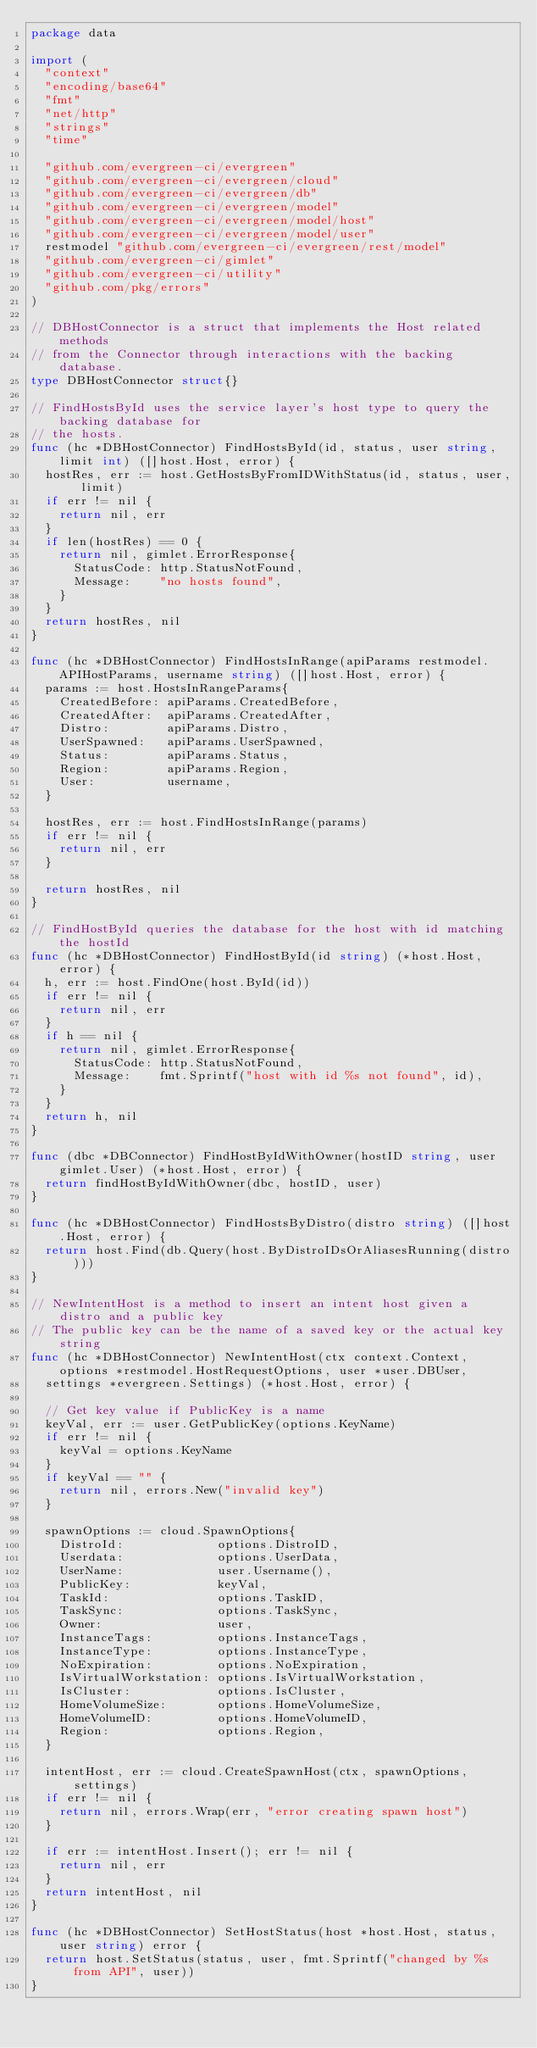Convert code to text. <code><loc_0><loc_0><loc_500><loc_500><_Go_>package data

import (
	"context"
	"encoding/base64"
	"fmt"
	"net/http"
	"strings"
	"time"

	"github.com/evergreen-ci/evergreen"
	"github.com/evergreen-ci/evergreen/cloud"
	"github.com/evergreen-ci/evergreen/db"
	"github.com/evergreen-ci/evergreen/model"
	"github.com/evergreen-ci/evergreen/model/host"
	"github.com/evergreen-ci/evergreen/model/user"
	restmodel "github.com/evergreen-ci/evergreen/rest/model"
	"github.com/evergreen-ci/gimlet"
	"github.com/evergreen-ci/utility"
	"github.com/pkg/errors"
)

// DBHostConnector is a struct that implements the Host related methods
// from the Connector through interactions with the backing database.
type DBHostConnector struct{}

// FindHostsById uses the service layer's host type to query the backing database for
// the hosts.
func (hc *DBHostConnector) FindHostsById(id, status, user string, limit int) ([]host.Host, error) {
	hostRes, err := host.GetHostsByFromIDWithStatus(id, status, user, limit)
	if err != nil {
		return nil, err
	}
	if len(hostRes) == 0 {
		return nil, gimlet.ErrorResponse{
			StatusCode: http.StatusNotFound,
			Message:    "no hosts found",
		}
	}
	return hostRes, nil
}

func (hc *DBHostConnector) FindHostsInRange(apiParams restmodel.APIHostParams, username string) ([]host.Host, error) {
	params := host.HostsInRangeParams{
		CreatedBefore: apiParams.CreatedBefore,
		CreatedAfter:  apiParams.CreatedAfter,
		Distro:        apiParams.Distro,
		UserSpawned:   apiParams.UserSpawned,
		Status:        apiParams.Status,
		Region:        apiParams.Region,
		User:          username,
	}

	hostRes, err := host.FindHostsInRange(params)
	if err != nil {
		return nil, err
	}

	return hostRes, nil
}

// FindHostById queries the database for the host with id matching the hostId
func (hc *DBHostConnector) FindHostById(id string) (*host.Host, error) {
	h, err := host.FindOne(host.ById(id))
	if err != nil {
		return nil, err
	}
	if h == nil {
		return nil, gimlet.ErrorResponse{
			StatusCode: http.StatusNotFound,
			Message:    fmt.Sprintf("host with id %s not found", id),
		}
	}
	return h, nil
}

func (dbc *DBConnector) FindHostByIdWithOwner(hostID string, user gimlet.User) (*host.Host, error) {
	return findHostByIdWithOwner(dbc, hostID, user)
}

func (hc *DBHostConnector) FindHostsByDistro(distro string) ([]host.Host, error) {
	return host.Find(db.Query(host.ByDistroIDsOrAliasesRunning(distro)))
}

// NewIntentHost is a method to insert an intent host given a distro and a public key
// The public key can be the name of a saved key or the actual key string
func (hc *DBHostConnector) NewIntentHost(ctx context.Context, options *restmodel.HostRequestOptions, user *user.DBUser,
	settings *evergreen.Settings) (*host.Host, error) {

	// Get key value if PublicKey is a name
	keyVal, err := user.GetPublicKey(options.KeyName)
	if err != nil {
		keyVal = options.KeyName
	}
	if keyVal == "" {
		return nil, errors.New("invalid key")
	}

	spawnOptions := cloud.SpawnOptions{
		DistroId:             options.DistroID,
		Userdata:             options.UserData,
		UserName:             user.Username(),
		PublicKey:            keyVal,
		TaskId:               options.TaskID,
		TaskSync:             options.TaskSync,
		Owner:                user,
		InstanceTags:         options.InstanceTags,
		InstanceType:         options.InstanceType,
		NoExpiration:         options.NoExpiration,
		IsVirtualWorkstation: options.IsVirtualWorkstation,
		IsCluster:            options.IsCluster,
		HomeVolumeSize:       options.HomeVolumeSize,
		HomeVolumeID:         options.HomeVolumeID,
		Region:               options.Region,
	}

	intentHost, err := cloud.CreateSpawnHost(ctx, spawnOptions, settings)
	if err != nil {
		return nil, errors.Wrap(err, "error creating spawn host")
	}

	if err := intentHost.Insert(); err != nil {
		return nil, err
	}
	return intentHost, nil
}

func (hc *DBHostConnector) SetHostStatus(host *host.Host, status, user string) error {
	return host.SetStatus(status, user, fmt.Sprintf("changed by %s from API", user))
}
</code> 